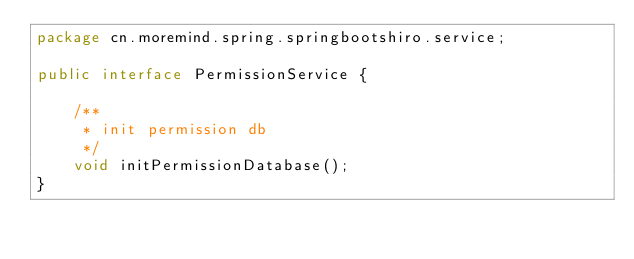Convert code to text. <code><loc_0><loc_0><loc_500><loc_500><_Java_>package cn.moremind.spring.springbootshiro.service;

public interface PermissionService {

    /**
     * init permission db
     */
    void initPermissionDatabase();
}
</code> 